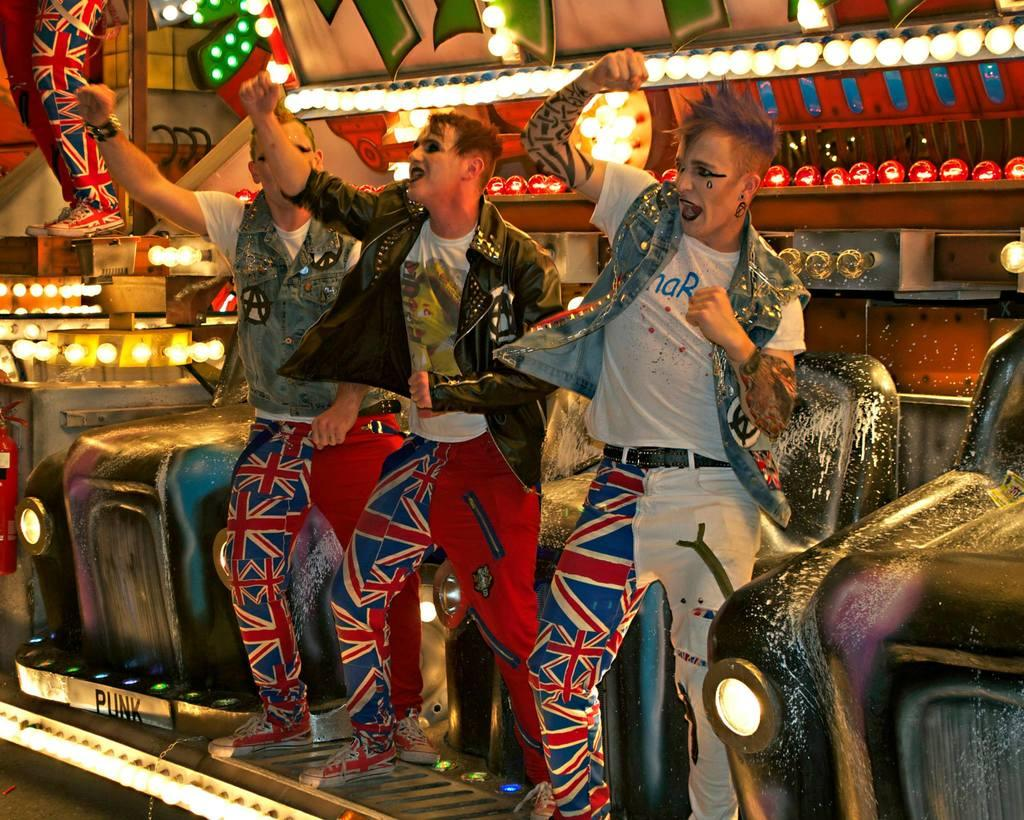How many men are in the image? There are three men in the image. What are the men doing in the image? The men are standing in the image. What are the men wearing in the image? The men are wearing costumes in the image. What can be seen in the background of the image? There are lights visible in the background of the image. Is there anyone else in the image besides the three men? Yes, there is a person in the top left corner of the image. What type of polish is the goose using to shine its feathers in the image? There is no goose present in the image, and therefore no polish or feathers to shine. Who is the friend of the person in the top left corner of the image? The provided facts do not mention any friends or relationships between the people in the image. 